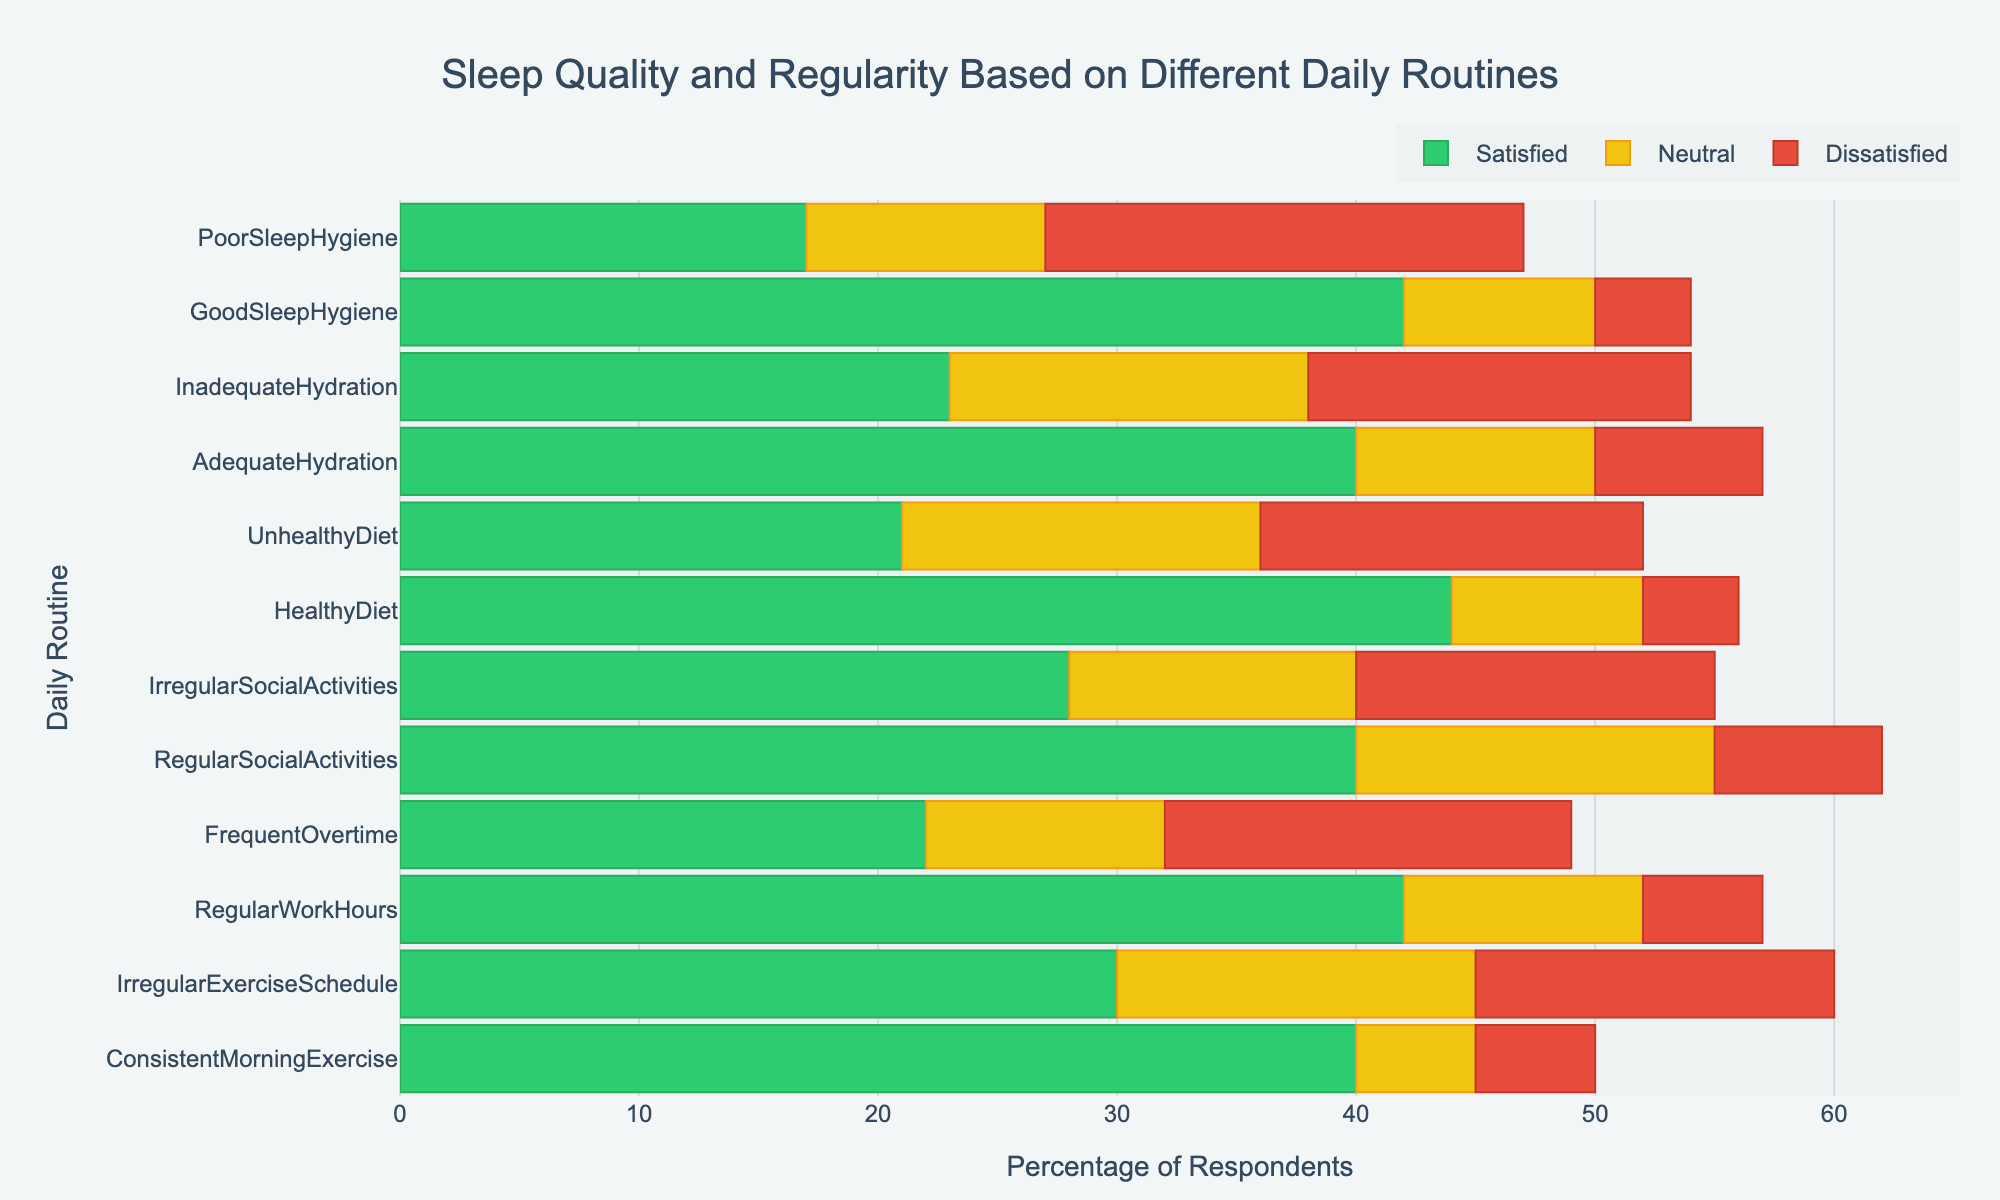Which daily routine shows the highest percentage of respondents who are highly satisfied with their sleep quality? The bar for "Highly Satisfied" is longest for "Good Sleep Hygiene," meaning it has the highest percentage among all routines.
Answer: Good Sleep Hygiene Which routine has the lowest percentage of satisfied respondents (highly + moderately satisfied)? The sum of "Highly Satisfied" and "Moderately Satisfied" is lowest for "Poor Sleep Hygiene"; visually, its bar is much shorter compared to others.
Answer: Poor Sleep Hygiene Compare the percentage of neutral responses between Regular Work Hours and Frequent Overtime. Which routine has a higher percentage? The bar for "Neutral" category shows that "Frequent Overtime" has a slightly higher value than "Regular Work Hours."
Answer: Frequent Overtime How many more respondents are highly satisfied with their sleep quality in those with Consistent Morning Exercise vs. those with an Unhealthy Diet? Highly Satisfied bar for "Consistent Morning Exercise" is 25 and for "Unhealthy Diet" it is 9. The difference is 25 - 9 = 16.
Answer: 16 What is the combined percentage of dissatisfied (moderately + highly dissatisfied) respondents for Irregular Social Activities? The sum of "Moderately Dissatisfied" and "Highly Dissatisfied" for "Irregular Social Activities" is 10 + 5 = 15.
Answer: 15 What is the visual difference in neutral responses between Adequate Hydration and Inadequate Hydration? Both "Adequate Hydration" and "Inadequate Hydration" have neutral responses nearly of the same length on the bar, indicating a similar percentage.
Answer: Similar Between Regular Social Activities and Irregular Exercise Schedule, which has a higher percentage of highly dissatisfied respondents? The "Highly Dissatisfied" bar is longer for "Irregular Exercise Schedule" than for "Regular Social Activities."
Answer: Irregular Exercise Schedule Which daily routine has a more closely balanced distribution of satisfied, neutral, and dissatisfied respondents? "Irregular Exercise Schedule" shows a relatively balanced distribution among the categories; the bars are more equal in length compared to others.
Answer: Irregular Exercise Schedule 